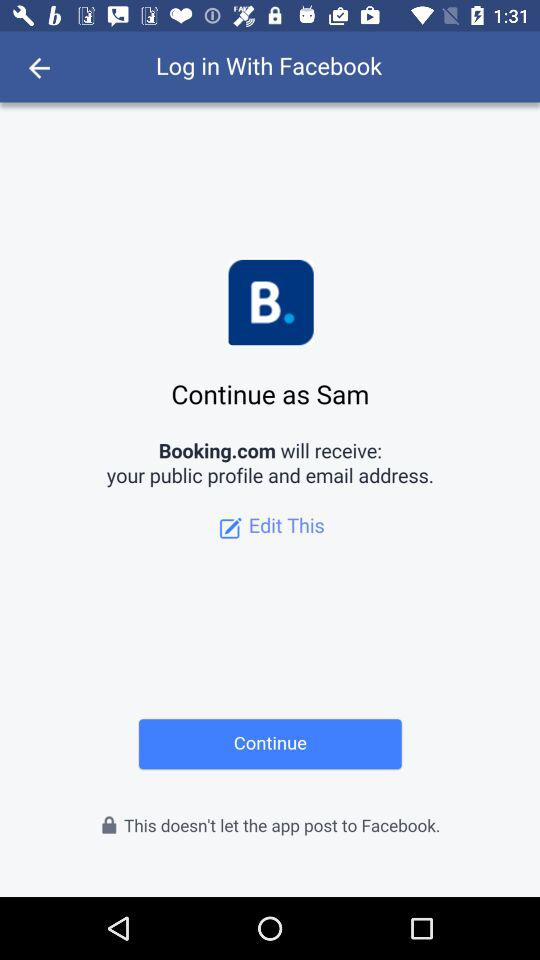What account am I using to log in? You are using your "Facebook" account to log in. 